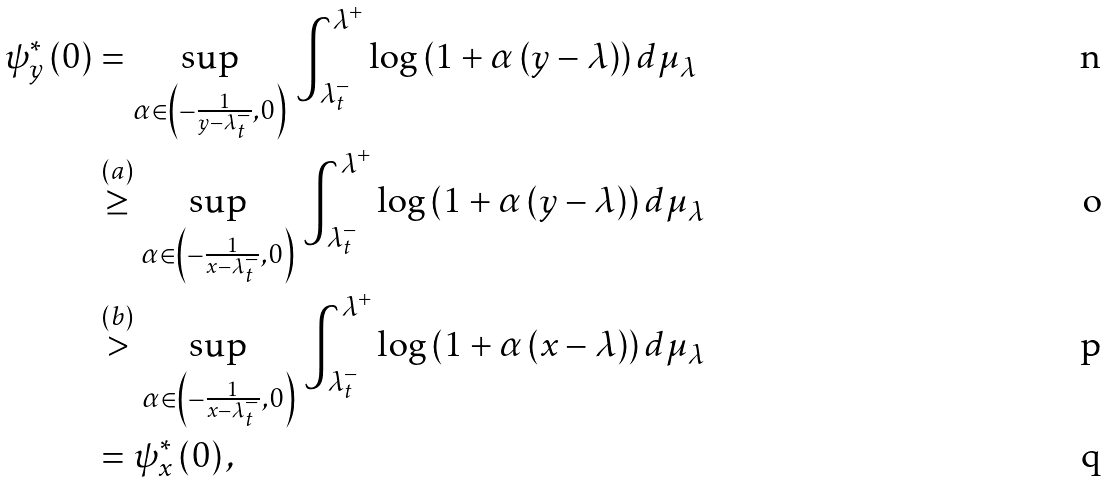<formula> <loc_0><loc_0><loc_500><loc_500>\psi _ { y } ^ { * } \left ( 0 \right ) & = \underset { \alpha \in \left ( - \frac { 1 } { y - \lambda _ { t } ^ { - } } , 0 \right ) } { \sup } \, \int _ { \lambda _ { t } ^ { - } } ^ { \lambda ^ { + } } \log \left ( 1 + \alpha \left ( y - \lambda \right ) \right ) d \mu _ { \lambda } \\ & \overset { \left ( a \right ) } { \geq } \underset { \alpha \in \left ( - \frac { 1 } { x - \lambda _ { t } ^ { - } } , 0 \right ) } { \sup } \, \int _ { \lambda _ { t } ^ { - } } ^ { \lambda ^ { + } } \log \left ( 1 + \alpha \left ( y - \lambda \right ) \right ) d \mu _ { \lambda } \\ & \overset { \left ( b \right ) } { > } \underset { \alpha \in \left ( - \frac { 1 } { x - \lambda _ { t } ^ { - } } , 0 \right ) } { \sup } \, \int _ { \lambda _ { t } ^ { - } } ^ { \lambda ^ { + } } \log \left ( 1 + \alpha \left ( x - \lambda \right ) \right ) d \mu _ { \lambda } \\ & = \psi _ { x } ^ { * } \left ( 0 \right ) ,</formula> 